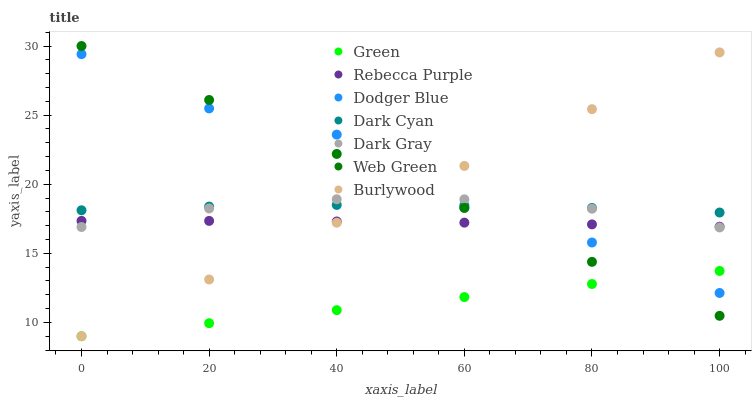Does Green have the minimum area under the curve?
Answer yes or no. Yes. Does Dodger Blue have the maximum area under the curve?
Answer yes or no. Yes. Does Web Green have the minimum area under the curve?
Answer yes or no. No. Does Web Green have the maximum area under the curve?
Answer yes or no. No. Is Green the smoothest?
Answer yes or no. Yes. Is Dodger Blue the roughest?
Answer yes or no. Yes. Is Web Green the smoothest?
Answer yes or no. No. Is Web Green the roughest?
Answer yes or no. No. Does Burlywood have the lowest value?
Answer yes or no. Yes. Does Web Green have the lowest value?
Answer yes or no. No. Does Web Green have the highest value?
Answer yes or no. Yes. Does Dark Gray have the highest value?
Answer yes or no. No. Is Green less than Dark Cyan?
Answer yes or no. Yes. Is Dark Gray greater than Green?
Answer yes or no. Yes. Does Green intersect Burlywood?
Answer yes or no. Yes. Is Green less than Burlywood?
Answer yes or no. No. Is Green greater than Burlywood?
Answer yes or no. No. Does Green intersect Dark Cyan?
Answer yes or no. No. 